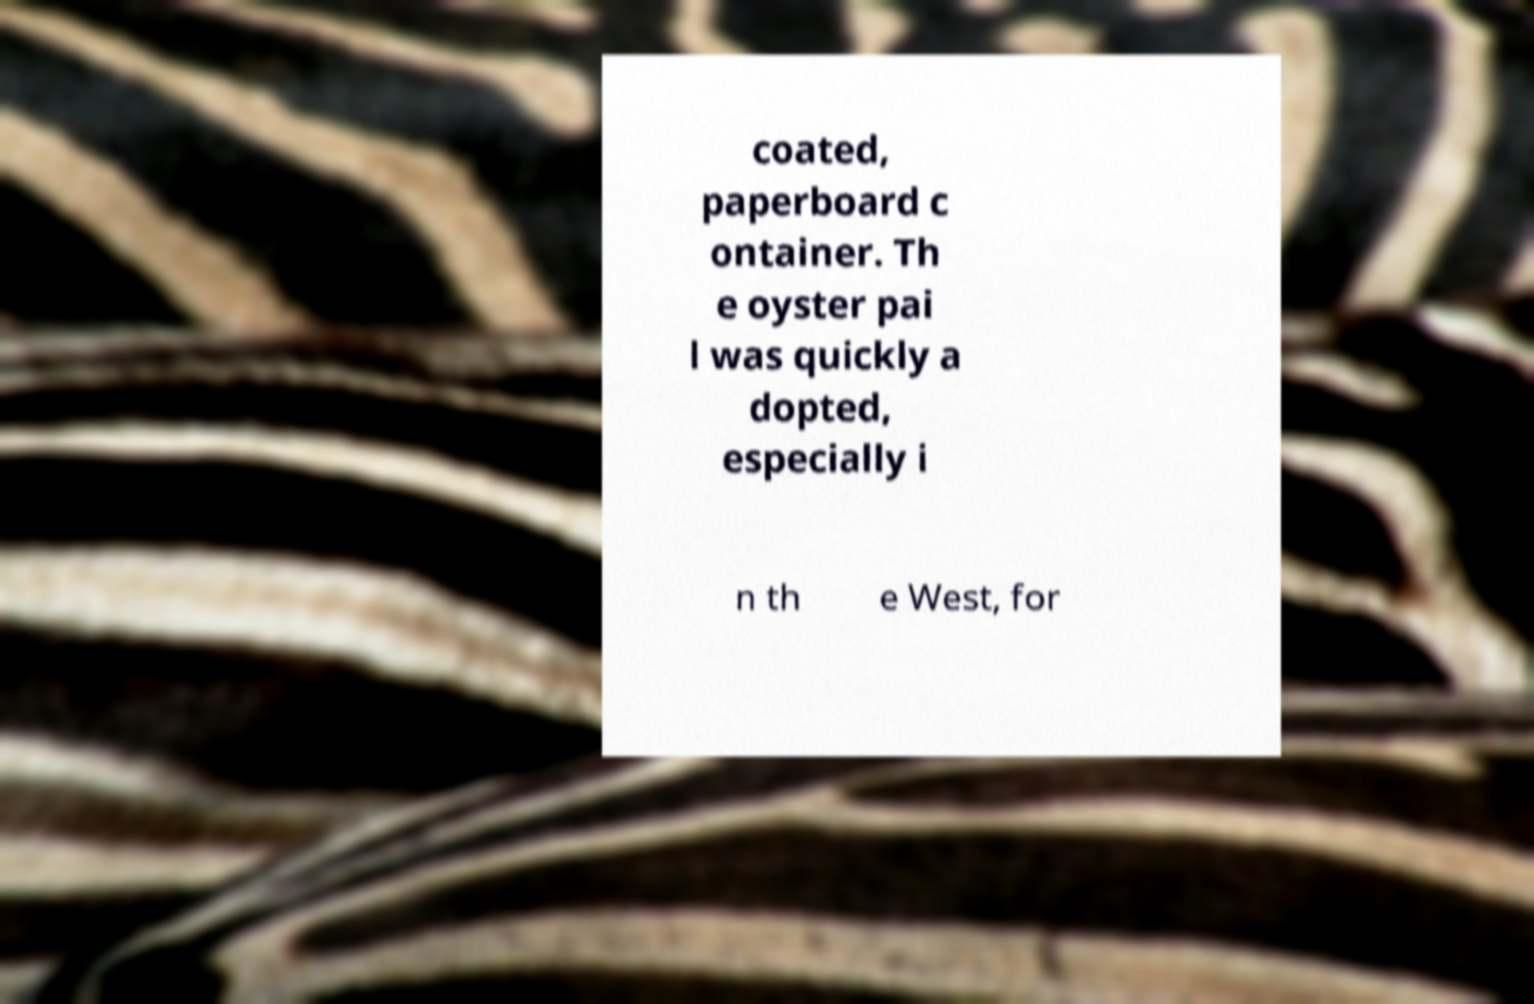I need the written content from this picture converted into text. Can you do that? coated, paperboard c ontainer. Th e oyster pai l was quickly a dopted, especially i n th e West, for 